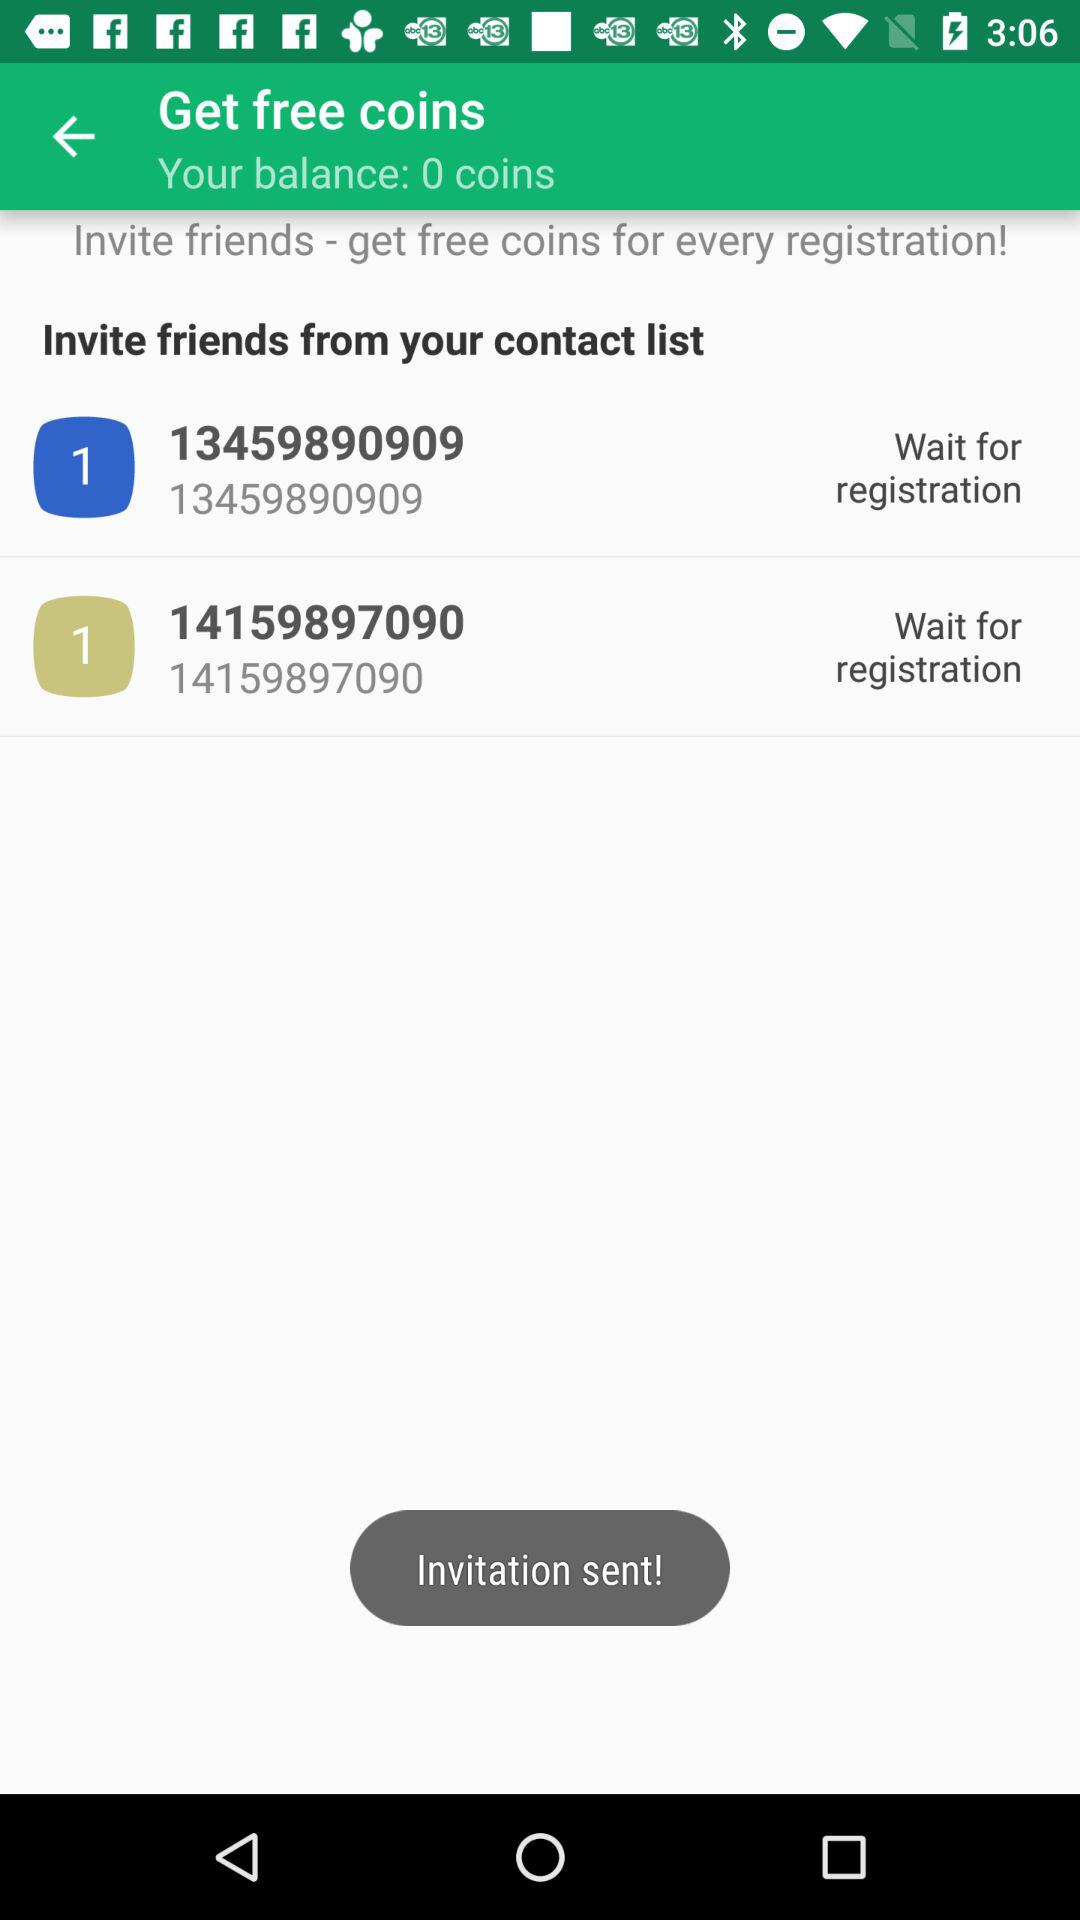How many friends are invited?
When the provided information is insufficient, respond with <no answer>. <no answer> 